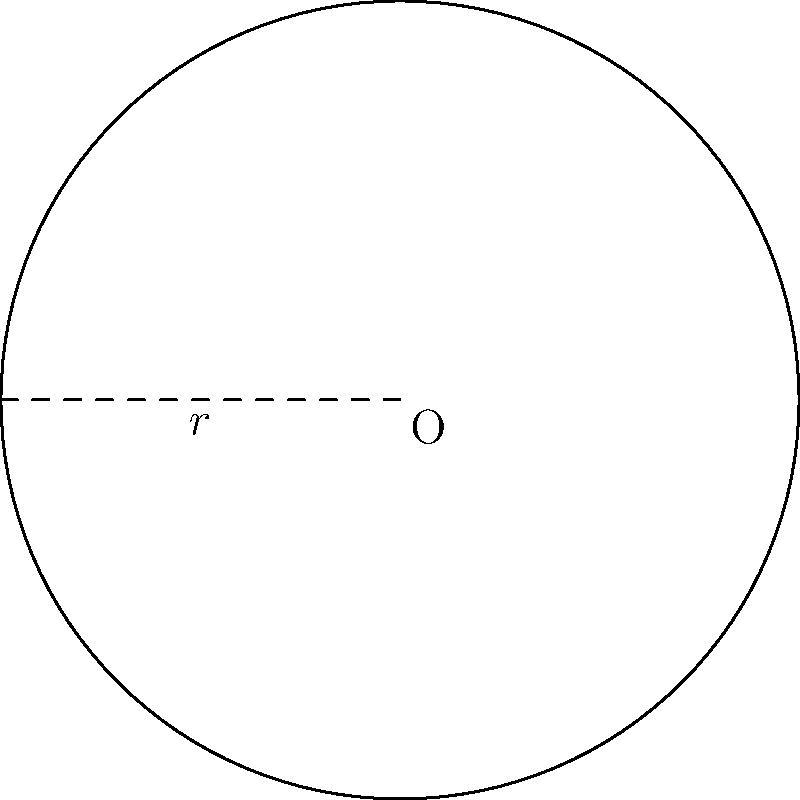A circular military encampment from the Roman era has a radius of 50 meters. What is the total area of the encampment, and how much fencing would be required to secure its perimeter? Round your answers to the nearest whole number. To solve this problem, we need to use the formulas for the area of a circle and the circumference of a circle.

1. Area of a circle:
   The formula is $A = \pi r^2$, where $r$ is the radius.
   $A = \pi \cdot 50^2 = 7,853.98... \text{ m}^2$

2. Circumference of a circle (for the fencing):
   The formula is $C = 2\pi r$, where $r$ is the radius.
   $C = 2\pi \cdot 50 = 314.16... \text{ m}$

3. Rounding to the nearest whole number:
   Area: 7,854 m²
   Circumference: 314 m

This circular design was common in Roman military camps (castra) and provided strategic advantages in terms of defense and organization.
Answer: Area: 7,854 m², Fencing: 314 m 